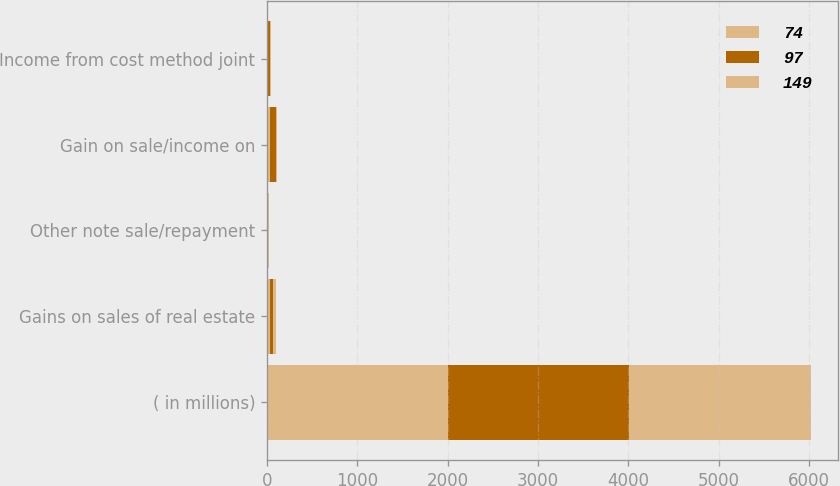<chart> <loc_0><loc_0><loc_500><loc_500><stacked_bar_chart><ecel><fcel>( in millions)<fcel>Gains on sales of real estate<fcel>Other note sale/repayment<fcel>Gain on sale/income on<fcel>Income from cost method joint<nl><fcel>74<fcel>2007<fcel>39<fcel>1<fcel>31<fcel>14<nl><fcel>97<fcel>2006<fcel>26<fcel>2<fcel>68<fcel>15<nl><fcel>149<fcel>2005<fcel>34<fcel>25<fcel>7<fcel>14<nl></chart> 